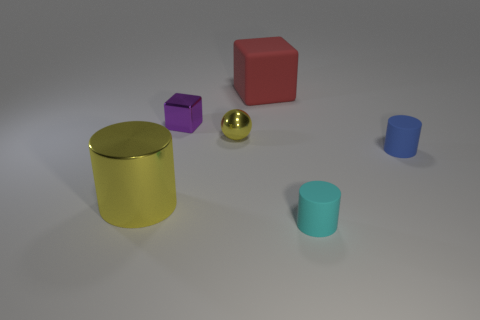Subtract all rubber cylinders. How many cylinders are left? 1 Add 2 brown shiny cylinders. How many objects exist? 8 Subtract all red cubes. How many cubes are left? 1 Subtract all spheres. How many objects are left? 5 Subtract 2 blocks. How many blocks are left? 0 Subtract all cyan cylinders. Subtract all green blocks. How many cylinders are left? 2 Subtract all large yellow cylinders. Subtract all large matte blocks. How many objects are left? 4 Add 5 red matte objects. How many red matte objects are left? 6 Add 3 purple shiny cubes. How many purple shiny cubes exist? 4 Subtract 0 brown spheres. How many objects are left? 6 